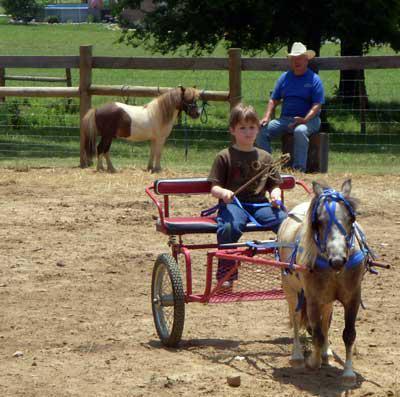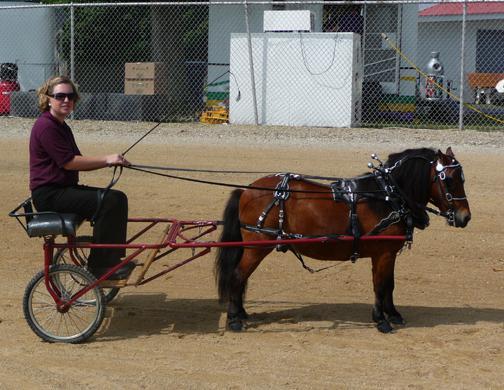The first image is the image on the left, the second image is the image on the right. For the images displayed, is the sentence "One image shows a child in blue jeans without a hat holding out at least one arm while riding a two-wheeled cart pulled across dirt by a pony." factually correct? Answer yes or no. Yes. The first image is the image on the left, the second image is the image on the right. Considering the images on both sides, is "there is at least one pony pulling a cart, there is a man in a blue tshirt and a cowboy hat sitting" valid? Answer yes or no. Yes. 